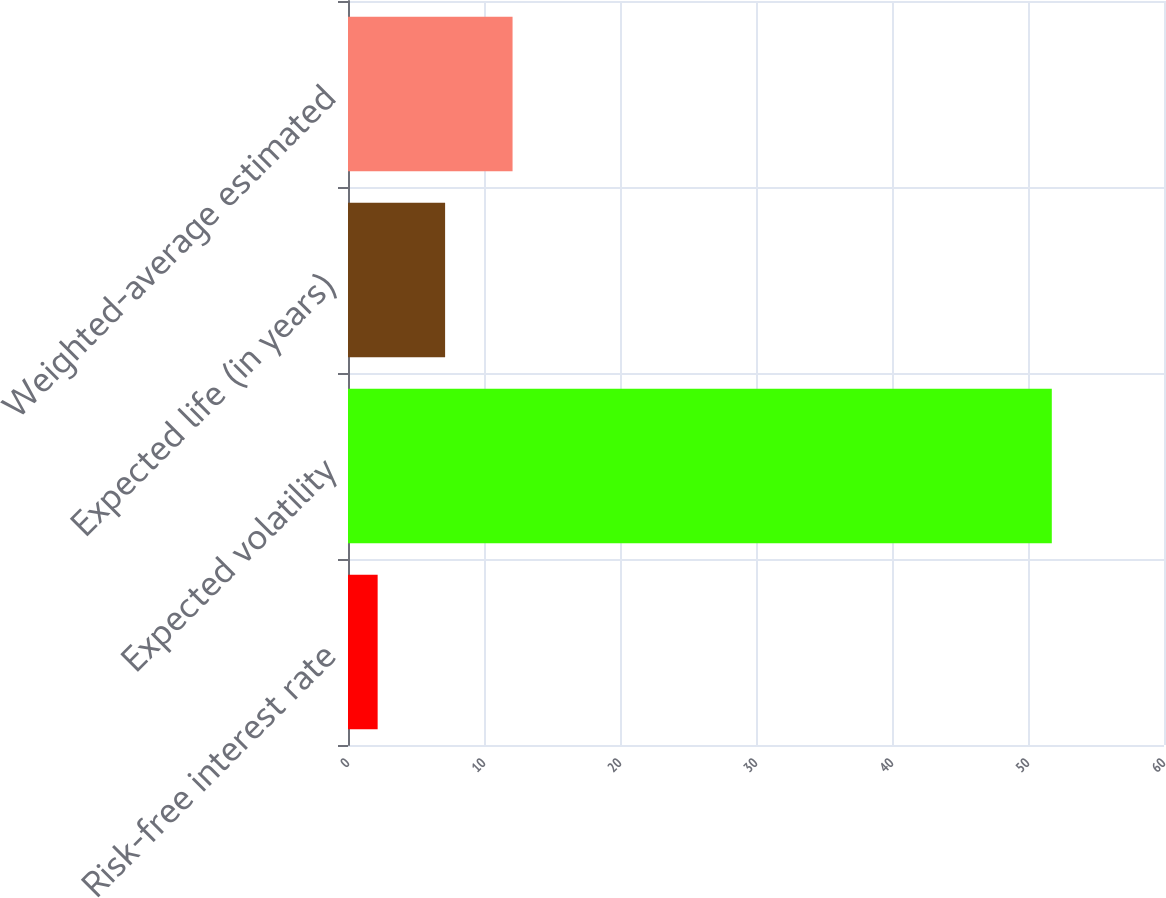Convert chart. <chart><loc_0><loc_0><loc_500><loc_500><bar_chart><fcel>Risk-free interest rate<fcel>Expected volatility<fcel>Expected life (in years)<fcel>Weighted-average estimated<nl><fcel>2.18<fcel>51.75<fcel>7.14<fcel>12.1<nl></chart> 